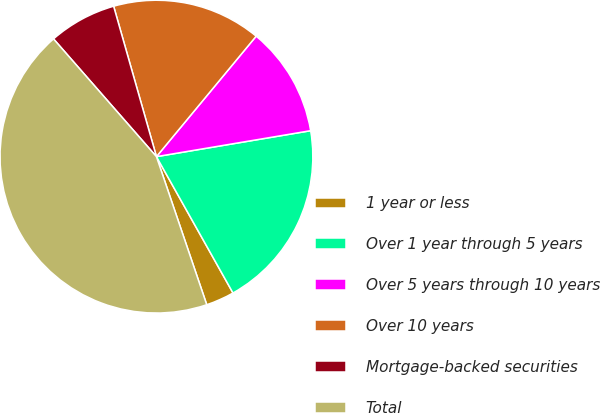Convert chart to OTSL. <chart><loc_0><loc_0><loc_500><loc_500><pie_chart><fcel>1 year or less<fcel>Over 1 year through 5 years<fcel>Over 5 years through 10 years<fcel>Over 10 years<fcel>Mortgage-backed securities<fcel>Total<nl><fcel>2.93%<fcel>19.51%<fcel>11.34%<fcel>15.42%<fcel>7.02%<fcel>43.78%<nl></chart> 